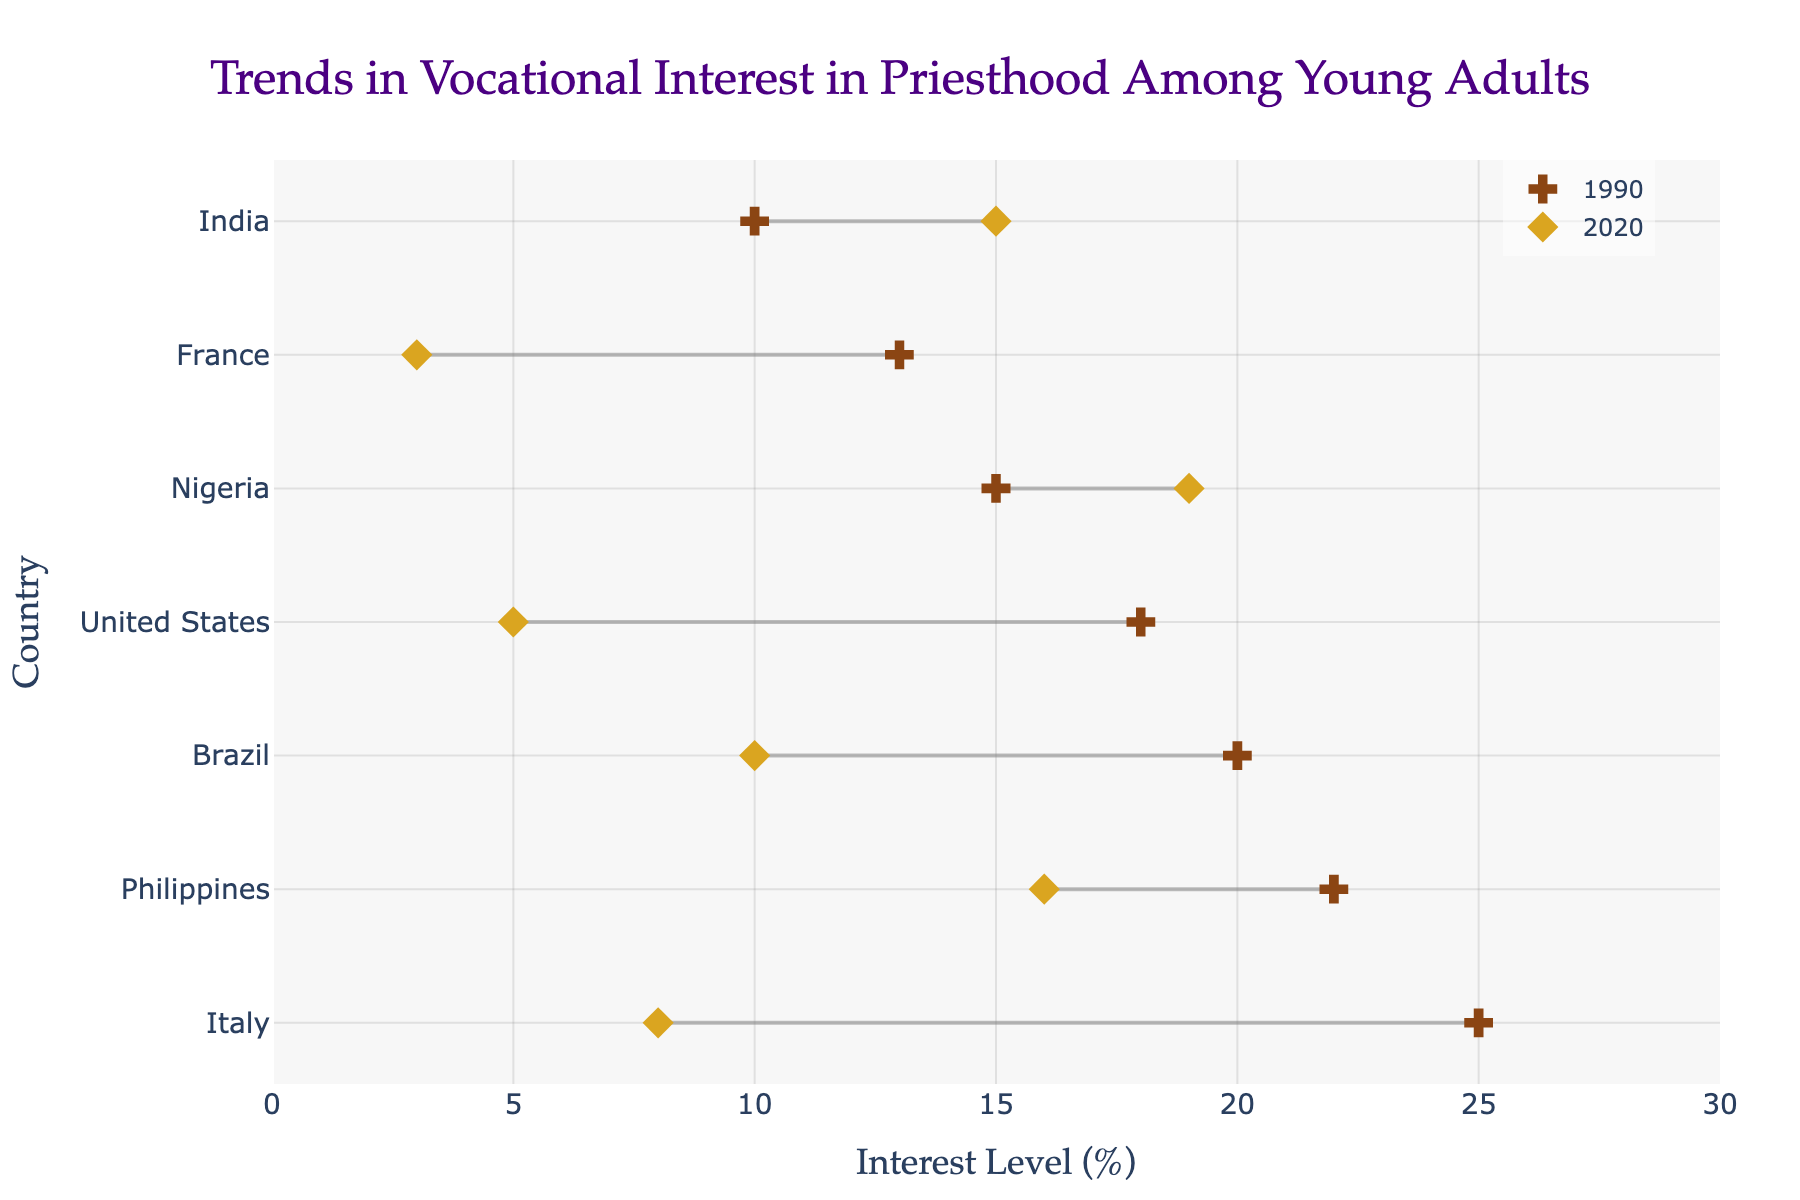What is the title of the chart? The chart's title is displayed at the top center of the figure. It reads "Trends in Vocational Interest in Priesthood Among Young Adults".
Answer: Trends in Vocational Interest in Priesthood Among Young Adults Which country had the highest interest in priesthood in 1990? To find this, look at the position of the markers for 1990 and see which one is the furthest to the right. Italy has the highest interest level at 25%.
Answer: Italy In which country did the interest level decline the most from 1990 to 2020? Look at the two markers for each country and check the length of the connecting lines. France shows the greatest decline, falling from 13% to 3%, which is a drop of 10 percentage points.
Answer: France Which countries showed an increase in interest levels from 1990 to 2020? Check the markers for each country, see where the 2020 markers are higher than the 1990 markers. In this figure, Nigeria and India are the ones that showed an increase.
Answer: Nigeria, India What is the range of the interest levels shown on the x-axis? Review the labels on the x-axis. The range of interest levels is from 0% to 30%.
Answer: 0%-30% By how many percentage points did the interest level in the Philippines decrease from 1990 to 2020? Locate the markers for the Philippines and calculate the difference between 1990 and 2020. The interest decreased from 22% to 16%, a decrease of 6 percentage points.
Answer: 6 percentage points How many countries are included in the dataset? Count the number of unique countries on the y-axis. There are 7 countries included.
Answer: 7 Which country had the smallest change in interest levels from 1990 to 2020? Compare the lengths of the lines connecting each pair of markers. Brazil shows a change from 15% to 10%, which is a drop of 5 percentage points.
Answer: Brazil Between Italy and the United States, which had a lower interest level in 2020? Compare the 2020 markers for both countries. The United States had a lower interest level at 5% while Italy was at 8%.
Answer: United States What percentage point change did Nigeria experience between 1990 and 2020? Check the markers for Nigeria and determine the difference between the two years. Nigeria's interest level increased from 14% to 19%, a change of 5 percentage points.
Answer: 5 percentage points 